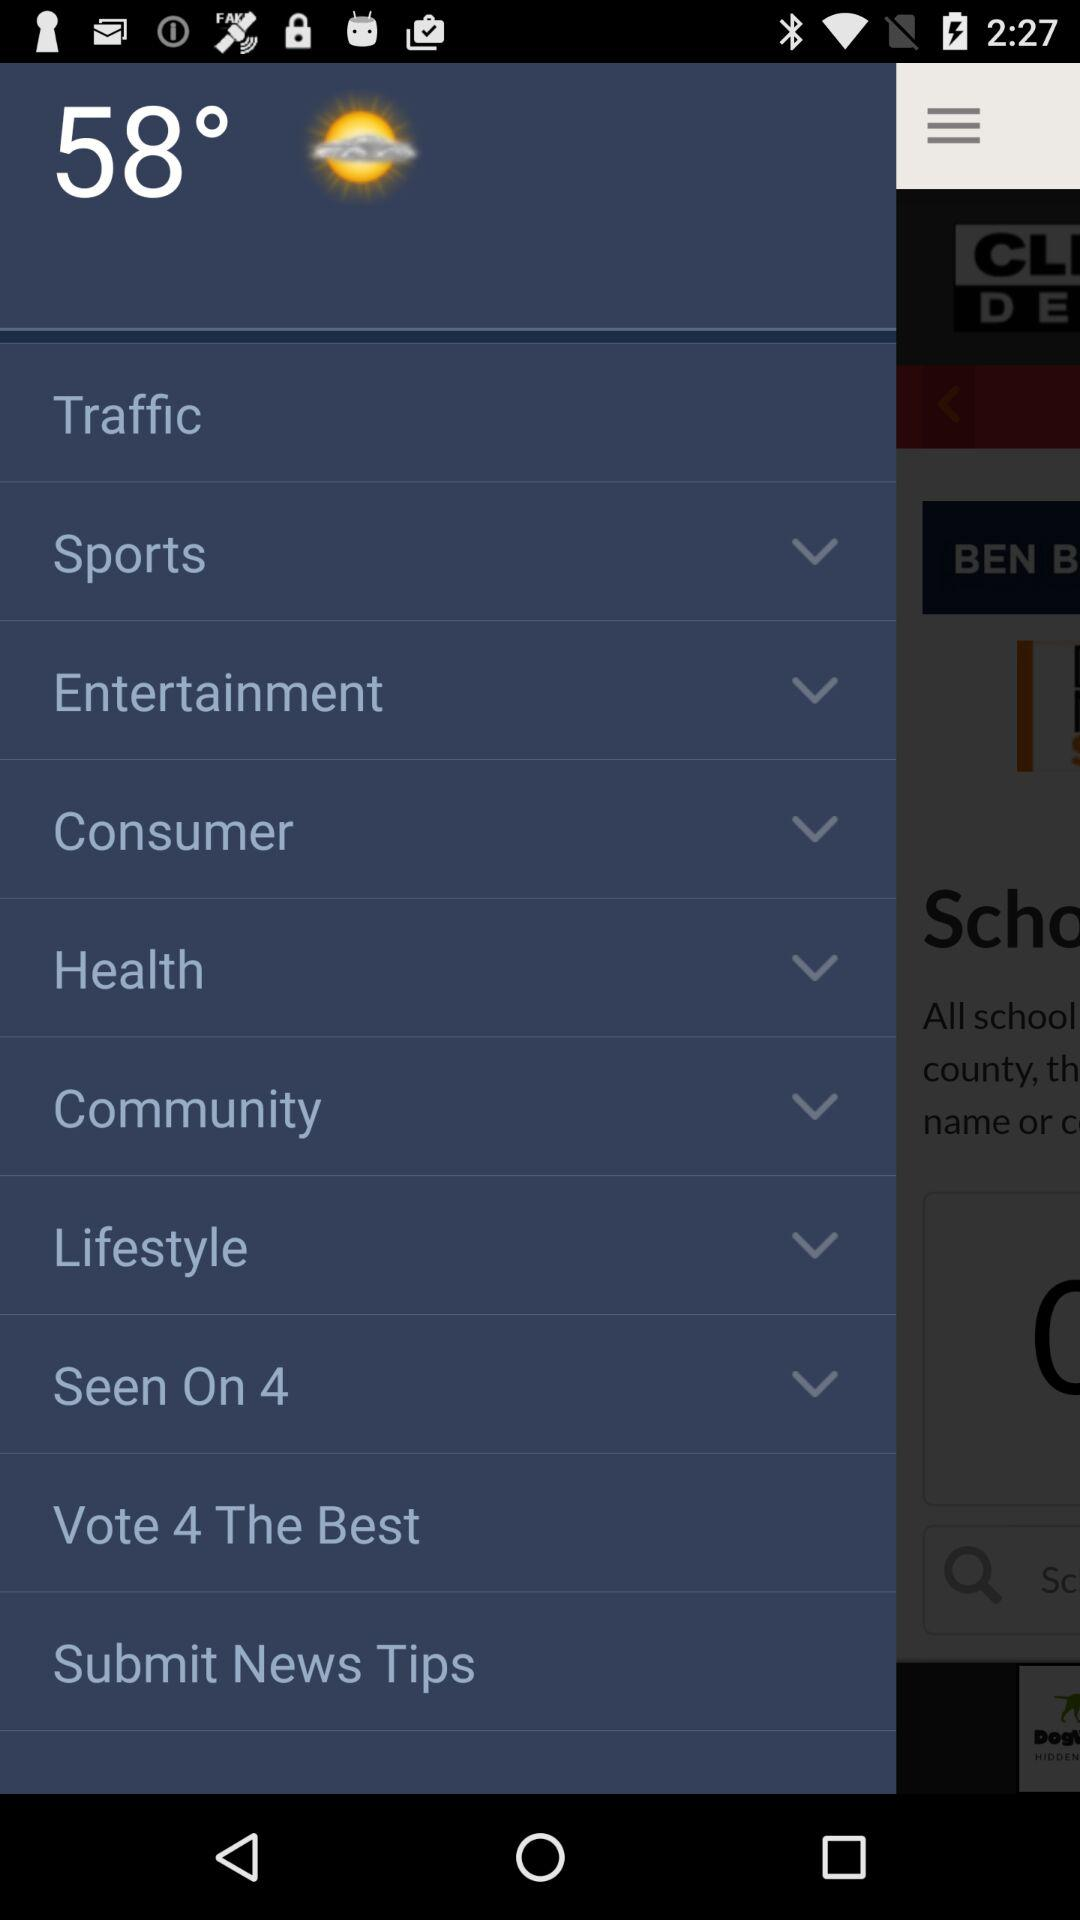What's the temperature? The temperature is 58°. 